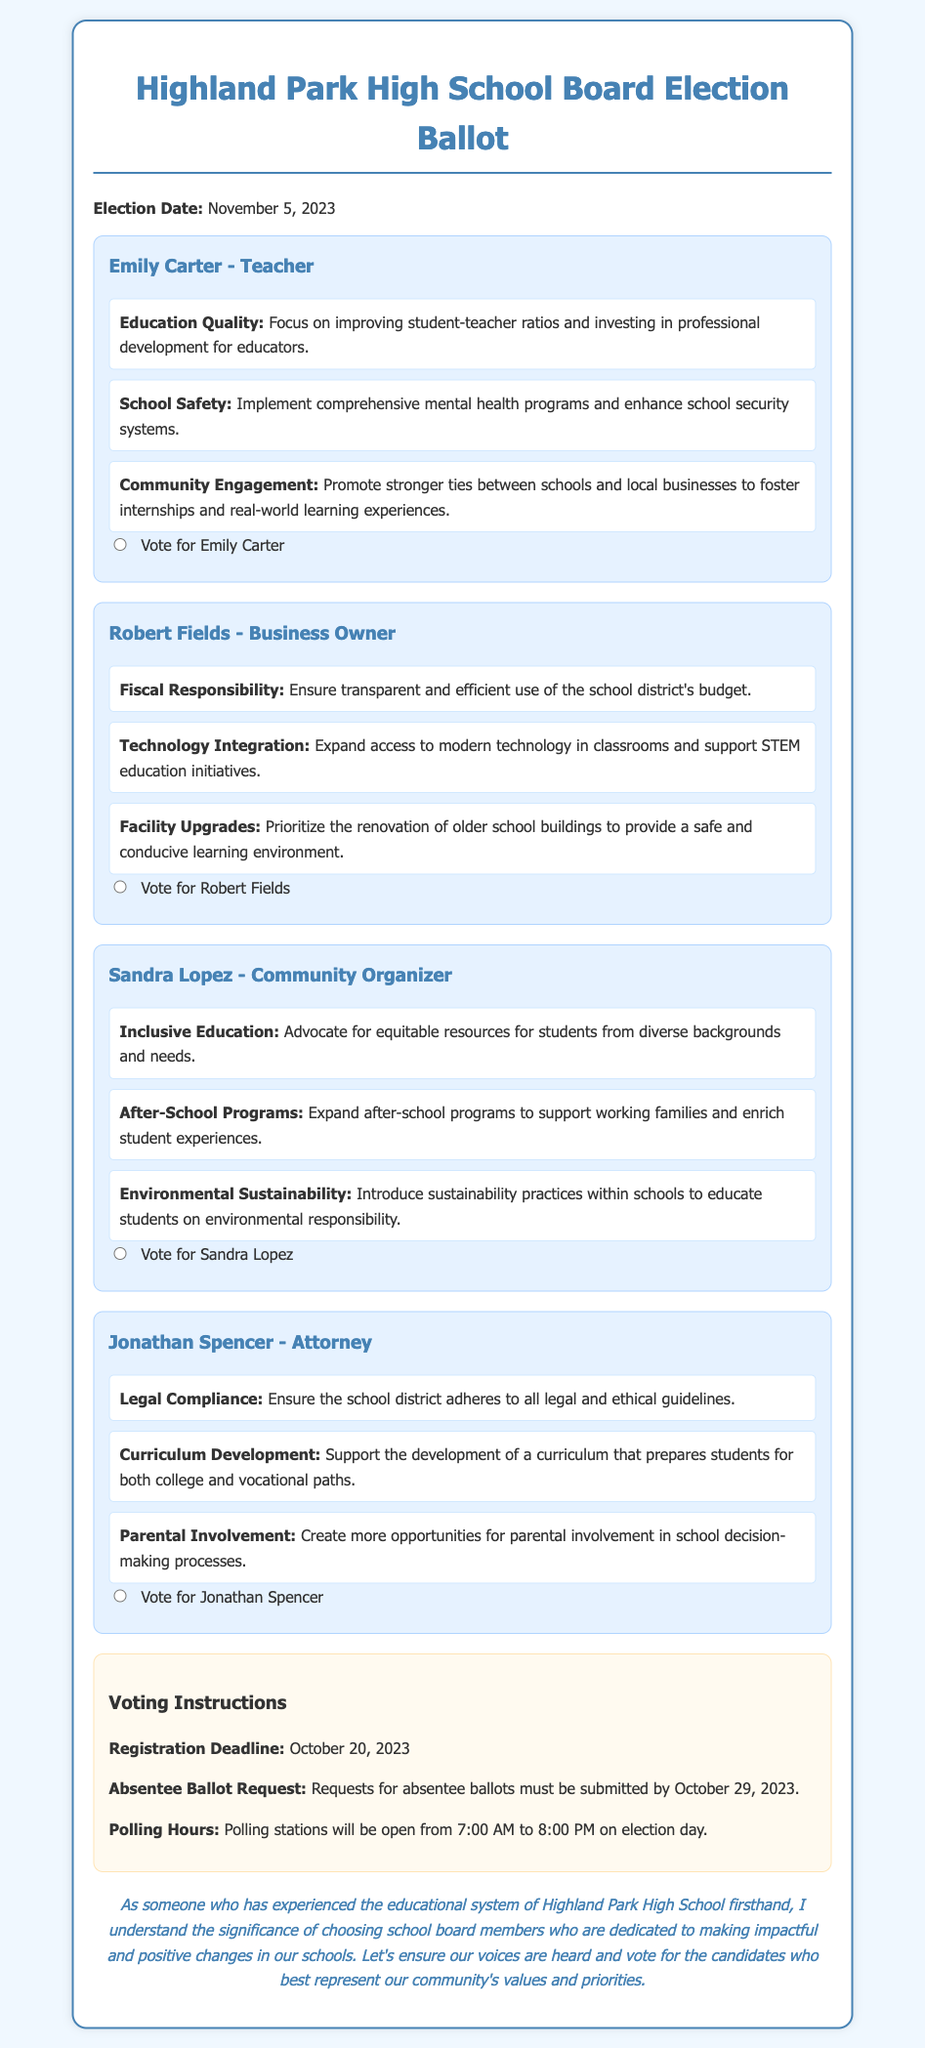What is the election date? The election date is explicitly stated in the document.
Answer: November 5, 2023 Who is the candidate from the teaching profession? The document lists each candidate along with their professions, and one is identified as a teacher.
Answer: Emily Carter What platform item focuses on educational equity? One candidate’s platform emphasizes resources for students from diverse backgrounds and needs.
Answer: Inclusive Education What is the deadline for absentee ballot requests? The document specifies a deadline for requesting absentee ballots.
Answer: October 29, 2023 Which candidate prioritizes fiscal responsibility? The candidate's platform includes a focus on transparent budget use.
Answer: Robert Fields How many candidates are listed in the document? The document outlines four candidates participating in the election.
Answer: Four What is one of the community engagement goals mentioned by Emily Carter? The document lists specific goals of each candidate's platform, which includes a focus on community ties.
Answer: Stronger ties between schools and local businesses What are polling station hours on election day? The document provides the hours that polling stations will be open.
Answer: 7:00 AM to 8:00 PM What is the candidate's profession who advocates for environmental sustainability? The candidate's profession is mentioned alongside their advocacy platform.
Answer: Community Organizer 